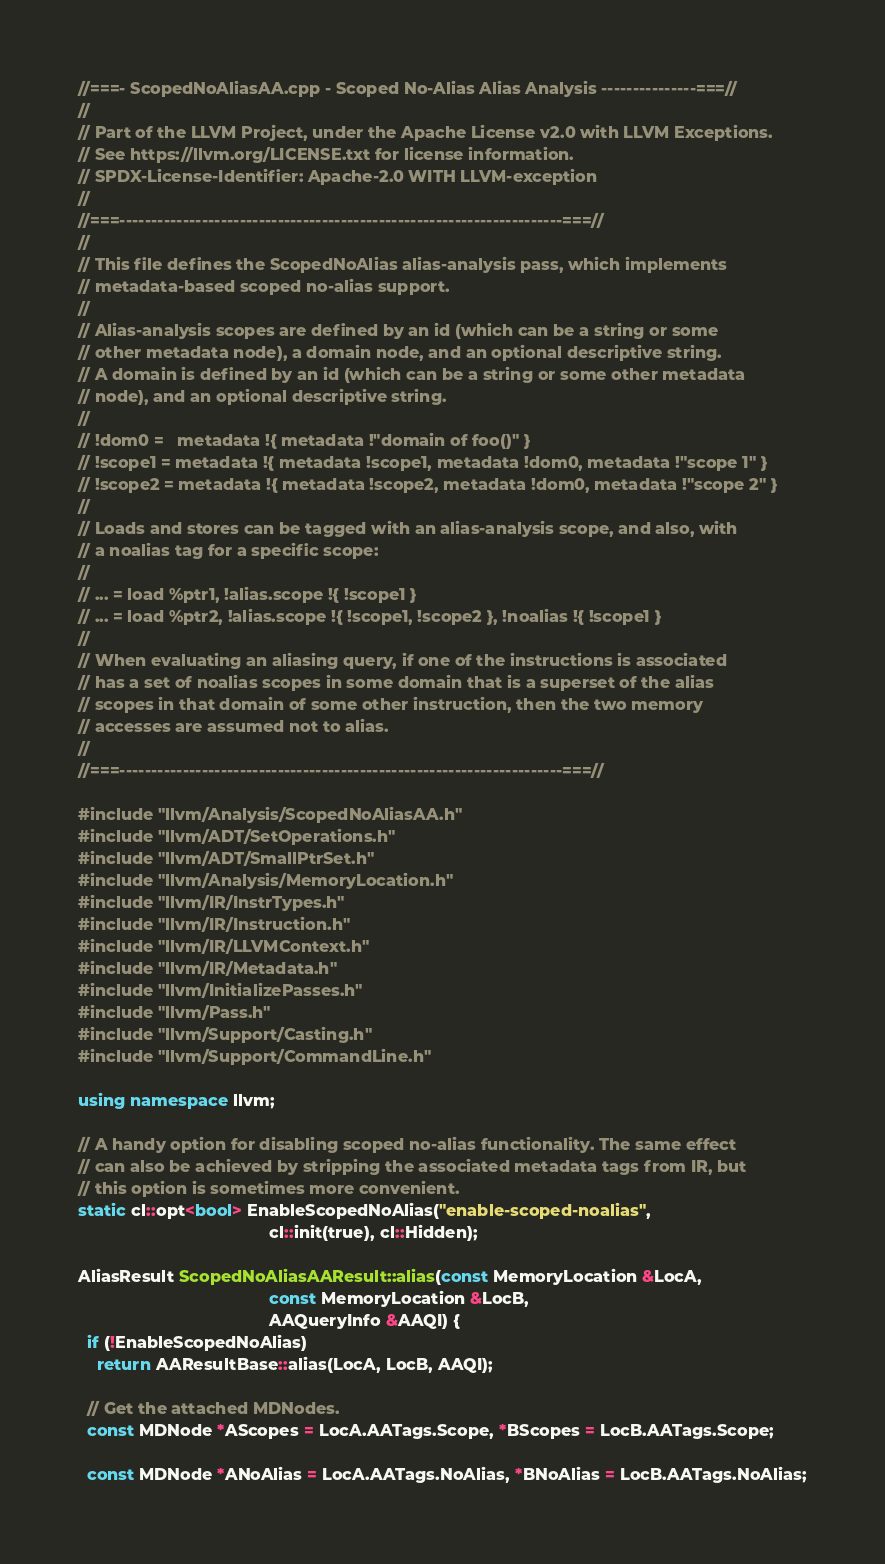Convert code to text. <code><loc_0><loc_0><loc_500><loc_500><_C++_>//===- ScopedNoAliasAA.cpp - Scoped No-Alias Alias Analysis ---------------===//
//
// Part of the LLVM Project, under the Apache License v2.0 with LLVM Exceptions.
// See https://llvm.org/LICENSE.txt for license information.
// SPDX-License-Identifier: Apache-2.0 WITH LLVM-exception
//
//===----------------------------------------------------------------------===//
//
// This file defines the ScopedNoAlias alias-analysis pass, which implements
// metadata-based scoped no-alias support.
//
// Alias-analysis scopes are defined by an id (which can be a string or some
// other metadata node), a domain node, and an optional descriptive string.
// A domain is defined by an id (which can be a string or some other metadata
// node), and an optional descriptive string.
//
// !dom0 =   metadata !{ metadata !"domain of foo()" }
// !scope1 = metadata !{ metadata !scope1, metadata !dom0, metadata !"scope 1" }
// !scope2 = metadata !{ metadata !scope2, metadata !dom0, metadata !"scope 2" }
//
// Loads and stores can be tagged with an alias-analysis scope, and also, with
// a noalias tag for a specific scope:
//
// ... = load %ptr1, !alias.scope !{ !scope1 }
// ... = load %ptr2, !alias.scope !{ !scope1, !scope2 }, !noalias !{ !scope1 }
//
// When evaluating an aliasing query, if one of the instructions is associated
// has a set of noalias scopes in some domain that is a superset of the alias
// scopes in that domain of some other instruction, then the two memory
// accesses are assumed not to alias.
//
//===----------------------------------------------------------------------===//

#include "llvm/Analysis/ScopedNoAliasAA.h"
#include "llvm/ADT/SetOperations.h"
#include "llvm/ADT/SmallPtrSet.h"
#include "llvm/Analysis/MemoryLocation.h"
#include "llvm/IR/InstrTypes.h"
#include "llvm/IR/Instruction.h"
#include "llvm/IR/LLVMContext.h"
#include "llvm/IR/Metadata.h"
#include "llvm/InitializePasses.h"
#include "llvm/Pass.h"
#include "llvm/Support/Casting.h"
#include "llvm/Support/CommandLine.h"

using namespace llvm;

// A handy option for disabling scoped no-alias functionality. The same effect
// can also be achieved by stripping the associated metadata tags from IR, but
// this option is sometimes more convenient.
static cl::opt<bool> EnableScopedNoAlias("enable-scoped-noalias",
                                         cl::init(true), cl::Hidden);

AliasResult ScopedNoAliasAAResult::alias(const MemoryLocation &LocA,
                                         const MemoryLocation &LocB,
                                         AAQueryInfo &AAQI) {
  if (!EnableScopedNoAlias)
    return AAResultBase::alias(LocA, LocB, AAQI);

  // Get the attached MDNodes.
  const MDNode *AScopes = LocA.AATags.Scope, *BScopes = LocB.AATags.Scope;

  const MDNode *ANoAlias = LocA.AATags.NoAlias, *BNoAlias = LocB.AATags.NoAlias;
</code> 